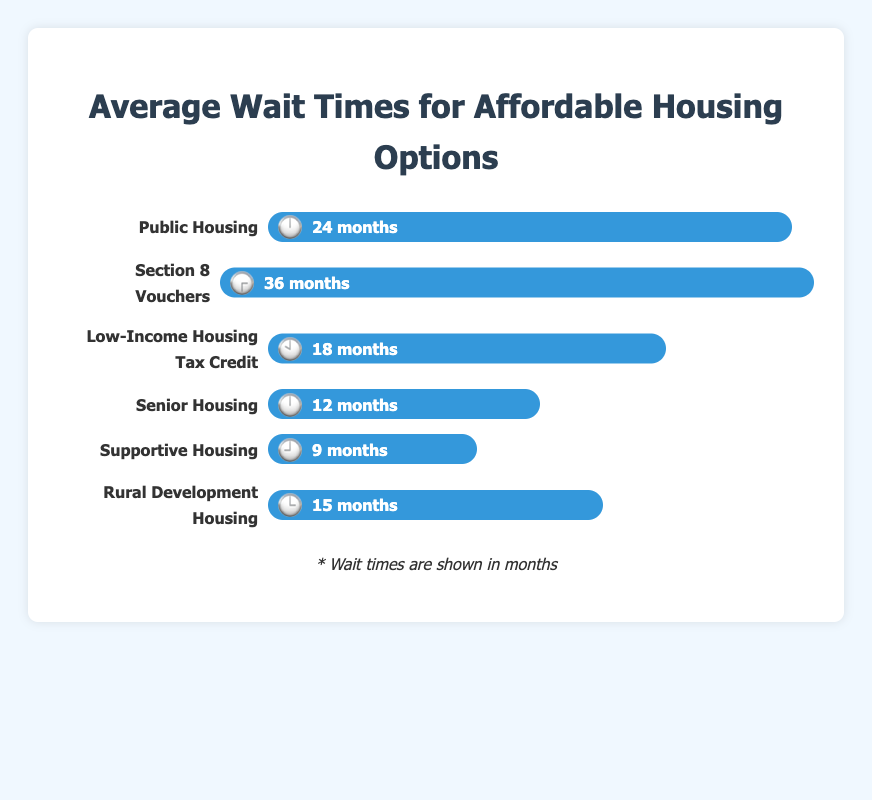What is the average wait time for Public Housing? The figure shows that the wait time for Public Housing is 24 months.
Answer: 24 months Which housing option has the shortest wait time? By comparing the wait times of all housing options in the figure, Supportive Housing has the shortest wait time of 9 months.
Answer: Supportive Housing How much longer is the wait time for Section 8 Vouchers compared to Senior Housing? The wait time for Section 8 Vouchers is 36 months and for Senior Housing it is 12 months. Subtract 12 from 36 to get the difference. 36 - 12 = 24 months.
Answer: 24 months What housing option has a wait time of 15 months? According to the figure, Rural Development Housing has a wait time of 15 months.
Answer: Rural Development Housing What is the total wait time if someone applied for both Public Housing and Low-Income Housing Tax Credit? The wait time for Public Housing is 24 months and for Low-Income Housing Tax Credit is 18 months. Add them together: 24 + 18 = 42 months.
Answer: 42 months Which housing option shows an emoji clock at 3 o'clock (🕒)? The figure displays that Rural Development Housing is represented by the emoji clock at 3 o'clock (🕒).
Answer: Rural Development Housing How many housing options have wait times of less than 20 months? By noting the wait times, Supportive Housing (9 months), Senior Housing (12 months), Low-Income Housing Tax Credit (18 months), and Rural Development Housing (15 months) are all under 20 months. There are 4 such options.
Answer: 4 Between Public Housing and Section 8 Vouchers, which has the longer wait time? The figure shows that Section 8 Vouchers have a wait time of 36 months, compared to Public Housing’s 24 months. Therefore, Section 8 Vouchers have the longer wait time.
Answer: Section 8 Vouchers What is the average wait time across all housing options? Add the wait times of each option: 24 + 36 + 18 + 12 + 9 + 15 = 114 months. There are 6 housing options, so divide 114 by 6 to get the average: 114 / 6 = 19 months.
Answer: 19 months Which housing options have exactly the same wait times? By examining the wait times, Public Housing (24 months) and Senior Housing (12 months) have duplicates in the emoji clocks but not the wait times. Thus, there are no options with the exact same wait times.
Answer: None 